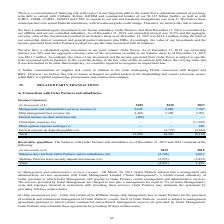From Golar Lng's financial document, In which years are the income(expenses) recorded for? The document contains multiple relevant values: 2019, 2018, 2017. From the document: "(in thousands of $) 2019 2018 2017 Management and administrative services revenue (i) 9,645 9,809 7,762 Ship management fees revenue ( (in thousands o..." Also, When did Golar Partners enter into an agreement with Golar Management? According to the financial document, March 30, 2011. The relevant text states: "nagement and administrative services revenue - On March 30, 2011, Golar Partners entered into a management and administrative services agreement with Golar Manageme..." Also, How much cash consideration was received from the sale of Golar Tundra? Based on the financial document, the answer is $107.2 million. Additionally, Which year was the management and administrative services revenue the highest? According to the financial document, 2018. The relevant text states: "(in thousands of $) 2019 2018 2017 Management and administrative services revenue (i) 9,645 9,809 7,762 Ship management fees reve..." Also, can you calculate: What was the change in ship management fees revenue from 2017 to 2018? Based on the calculation: 5,200 - 5,903 , the result is -703 (in thousands). This is based on the information: "809 7,762 Ship management fees revenue (ii) 4,460 5,200 5,903 Interest income on short-term loan (iii) (109) — — Charterhire expenses (iv) — — (17,423) Sha 762 Ship management fees revenue (ii) 4,460 ..." The key data points involved are: 5,200, 5,903. Also, can you calculate: What was the percentage change in total from 2018 to 2019? To answer this question, I need to perform calculations using the financial data. The calculation is: (13,996 - 10,230)/10,230 , which equals 36.81 (percentage). This is based on the information: "on deposits payable (vi) — (4,779) (4,622) Total 13,996 10,230 (8,152) osits payable (vi) — (4,779) (4,622) Total 13,996 10,230 (8,152)..." The key data points involved are: 10,230, 13,996. 